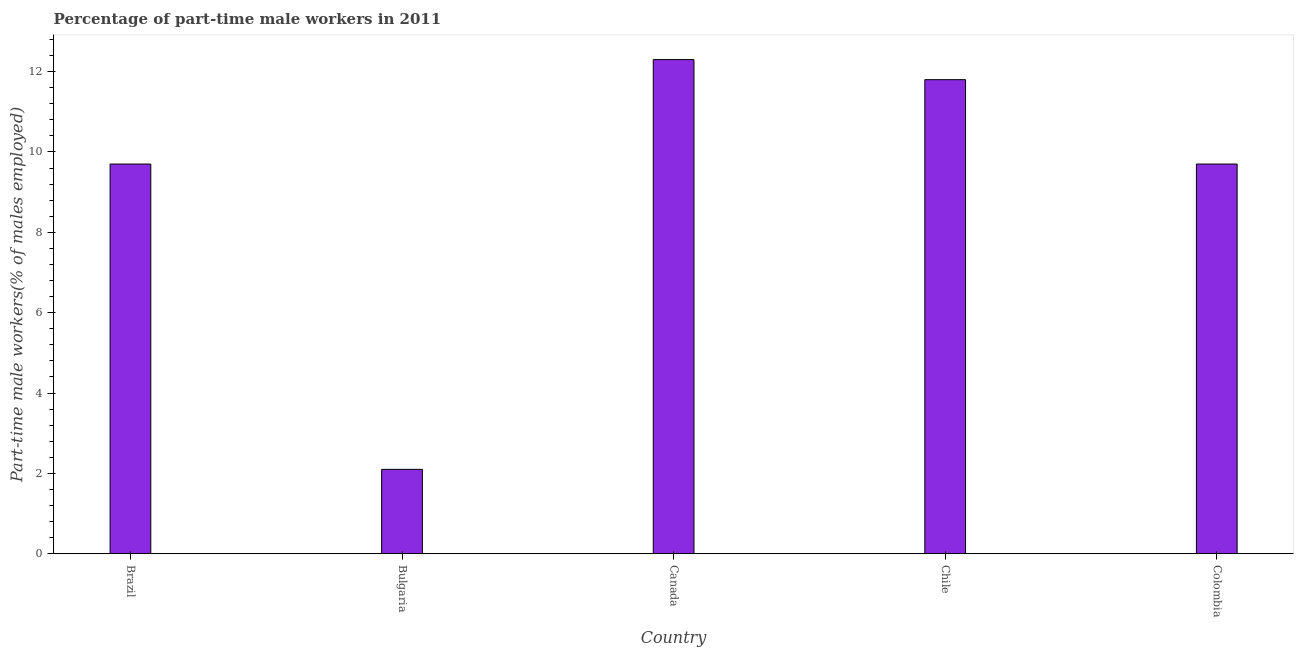Does the graph contain any zero values?
Make the answer very short. No. What is the title of the graph?
Ensure brevity in your answer.  Percentage of part-time male workers in 2011. What is the label or title of the X-axis?
Make the answer very short. Country. What is the label or title of the Y-axis?
Ensure brevity in your answer.  Part-time male workers(% of males employed). What is the percentage of part-time male workers in Chile?
Your answer should be compact. 11.8. Across all countries, what is the maximum percentage of part-time male workers?
Offer a very short reply. 12.3. Across all countries, what is the minimum percentage of part-time male workers?
Make the answer very short. 2.1. In which country was the percentage of part-time male workers maximum?
Your answer should be compact. Canada. In which country was the percentage of part-time male workers minimum?
Provide a succinct answer. Bulgaria. What is the sum of the percentage of part-time male workers?
Your answer should be very brief. 45.6. What is the average percentage of part-time male workers per country?
Provide a succinct answer. 9.12. What is the median percentage of part-time male workers?
Your response must be concise. 9.7. In how many countries, is the percentage of part-time male workers greater than 1.6 %?
Your response must be concise. 5. What is the ratio of the percentage of part-time male workers in Bulgaria to that in Chile?
Give a very brief answer. 0.18. Is the percentage of part-time male workers in Canada less than that in Chile?
Offer a very short reply. No. Is the difference between the percentage of part-time male workers in Bulgaria and Colombia greater than the difference between any two countries?
Provide a succinct answer. No. Is the sum of the percentage of part-time male workers in Canada and Chile greater than the maximum percentage of part-time male workers across all countries?
Make the answer very short. Yes. Are all the bars in the graph horizontal?
Make the answer very short. No. Are the values on the major ticks of Y-axis written in scientific E-notation?
Keep it short and to the point. No. What is the Part-time male workers(% of males employed) in Brazil?
Ensure brevity in your answer.  9.7. What is the Part-time male workers(% of males employed) in Bulgaria?
Give a very brief answer. 2.1. What is the Part-time male workers(% of males employed) in Canada?
Provide a succinct answer. 12.3. What is the Part-time male workers(% of males employed) in Chile?
Give a very brief answer. 11.8. What is the Part-time male workers(% of males employed) in Colombia?
Give a very brief answer. 9.7. What is the difference between the Part-time male workers(% of males employed) in Brazil and Bulgaria?
Give a very brief answer. 7.6. What is the difference between the Part-time male workers(% of males employed) in Brazil and Canada?
Your response must be concise. -2.6. What is the difference between the Part-time male workers(% of males employed) in Brazil and Colombia?
Your answer should be very brief. 0. What is the difference between the Part-time male workers(% of males employed) in Bulgaria and Chile?
Your answer should be very brief. -9.7. What is the difference between the Part-time male workers(% of males employed) in Bulgaria and Colombia?
Give a very brief answer. -7.6. What is the difference between the Part-time male workers(% of males employed) in Canada and Chile?
Provide a succinct answer. 0.5. What is the difference between the Part-time male workers(% of males employed) in Canada and Colombia?
Your response must be concise. 2.6. What is the difference between the Part-time male workers(% of males employed) in Chile and Colombia?
Make the answer very short. 2.1. What is the ratio of the Part-time male workers(% of males employed) in Brazil to that in Bulgaria?
Give a very brief answer. 4.62. What is the ratio of the Part-time male workers(% of males employed) in Brazil to that in Canada?
Your response must be concise. 0.79. What is the ratio of the Part-time male workers(% of males employed) in Brazil to that in Chile?
Your response must be concise. 0.82. What is the ratio of the Part-time male workers(% of males employed) in Bulgaria to that in Canada?
Provide a short and direct response. 0.17. What is the ratio of the Part-time male workers(% of males employed) in Bulgaria to that in Chile?
Keep it short and to the point. 0.18. What is the ratio of the Part-time male workers(% of males employed) in Bulgaria to that in Colombia?
Keep it short and to the point. 0.22. What is the ratio of the Part-time male workers(% of males employed) in Canada to that in Chile?
Provide a short and direct response. 1.04. What is the ratio of the Part-time male workers(% of males employed) in Canada to that in Colombia?
Make the answer very short. 1.27. What is the ratio of the Part-time male workers(% of males employed) in Chile to that in Colombia?
Offer a very short reply. 1.22. 